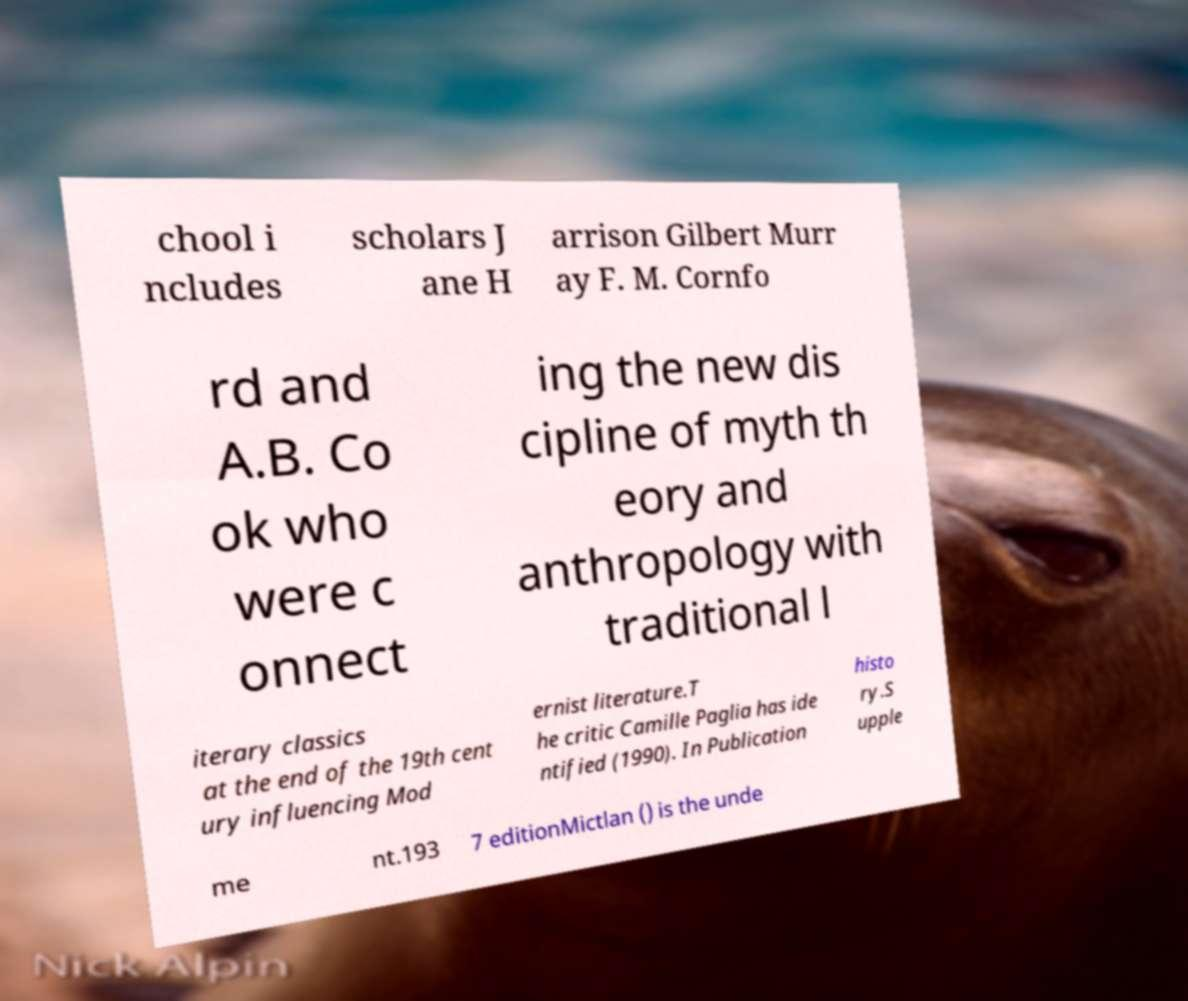Can you read and provide the text displayed in the image?This photo seems to have some interesting text. Can you extract and type it out for me? chool i ncludes scholars J ane H arrison Gilbert Murr ay F. M. Cornfo rd and A.B. Co ok who were c onnect ing the new dis cipline of myth th eory and anthropology with traditional l iterary classics at the end of the 19th cent ury influencing Mod ernist literature.T he critic Camille Paglia has ide ntified (1990). In Publication histo ry.S upple me nt.193 7 editionMictlan () is the unde 